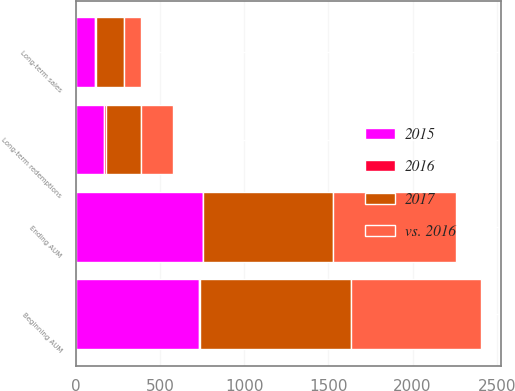Convert chart. <chart><loc_0><loc_0><loc_500><loc_500><stacked_bar_chart><ecel><fcel>Beginning AUM<fcel>Long-term sales<fcel>Long-term redemptions<fcel>Ending AUM<nl><fcel>2015<fcel>733.3<fcel>112.3<fcel>169.7<fcel>753.2<nl><fcel>vs. 2016<fcel>770.9<fcel>101.7<fcel>186.9<fcel>733.3<nl><fcel>2017<fcel>898<fcel>161.4<fcel>209<fcel>770.9<nl><fcel>2016<fcel>5<fcel>10<fcel>9<fcel>3<nl></chart> 